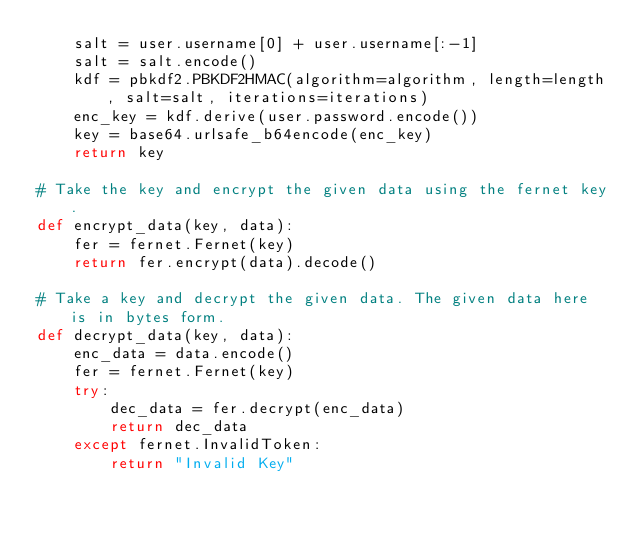<code> <loc_0><loc_0><loc_500><loc_500><_Python_>    salt = user.username[0] + user.username[:-1]
    salt = salt.encode()
    kdf = pbkdf2.PBKDF2HMAC(algorithm=algorithm, length=length, salt=salt, iterations=iterations)
    enc_key = kdf.derive(user.password.encode())
    key = base64.urlsafe_b64encode(enc_key)
    return key

# Take the key and encrypt the given data using the fernet key.
def encrypt_data(key, data):
    fer = fernet.Fernet(key)
    return fer.encrypt(data).decode()

# Take a key and decrypt the given data. The given data here is in bytes form.
def decrypt_data(key, data):
    enc_data = data.encode()
    fer = fernet.Fernet(key)
    try:
        dec_data = fer.decrypt(enc_data)
        return dec_data
    except fernet.InvalidToken:
        return "Invalid Key"
</code> 